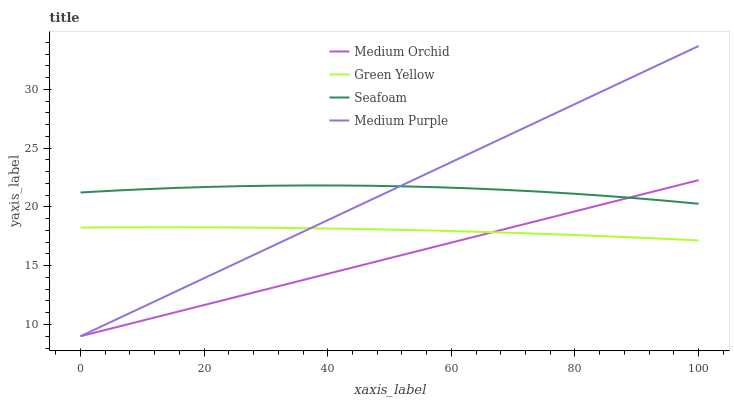Does Medium Orchid have the minimum area under the curve?
Answer yes or no. Yes. Does Seafoam have the maximum area under the curve?
Answer yes or no. Yes. Does Green Yellow have the minimum area under the curve?
Answer yes or no. No. Does Green Yellow have the maximum area under the curve?
Answer yes or no. No. Is Medium Orchid the smoothest?
Answer yes or no. Yes. Is Seafoam the roughest?
Answer yes or no. Yes. Is Green Yellow the smoothest?
Answer yes or no. No. Is Green Yellow the roughest?
Answer yes or no. No. Does Medium Purple have the lowest value?
Answer yes or no. Yes. Does Green Yellow have the lowest value?
Answer yes or no. No. Does Medium Purple have the highest value?
Answer yes or no. Yes. Does Medium Orchid have the highest value?
Answer yes or no. No. Is Green Yellow less than Seafoam?
Answer yes or no. Yes. Is Seafoam greater than Green Yellow?
Answer yes or no. Yes. Does Medium Orchid intersect Medium Purple?
Answer yes or no. Yes. Is Medium Orchid less than Medium Purple?
Answer yes or no. No. Is Medium Orchid greater than Medium Purple?
Answer yes or no. No. Does Green Yellow intersect Seafoam?
Answer yes or no. No. 